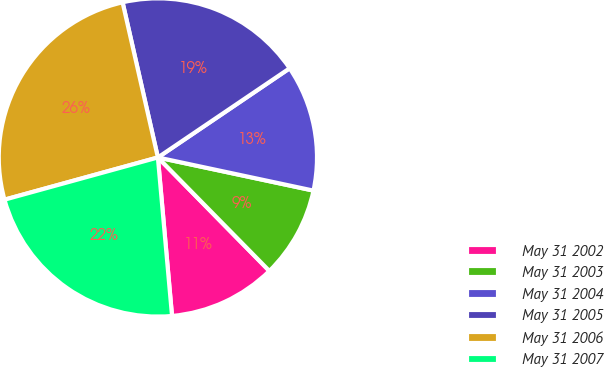Convert chart to OTSL. <chart><loc_0><loc_0><loc_500><loc_500><pie_chart><fcel>May 31 2002<fcel>May 31 2003<fcel>May 31 2004<fcel>May 31 2005<fcel>May 31 2006<fcel>May 31 2007<nl><fcel>10.94%<fcel>9.3%<fcel>12.81%<fcel>19.09%<fcel>25.71%<fcel>22.14%<nl></chart> 